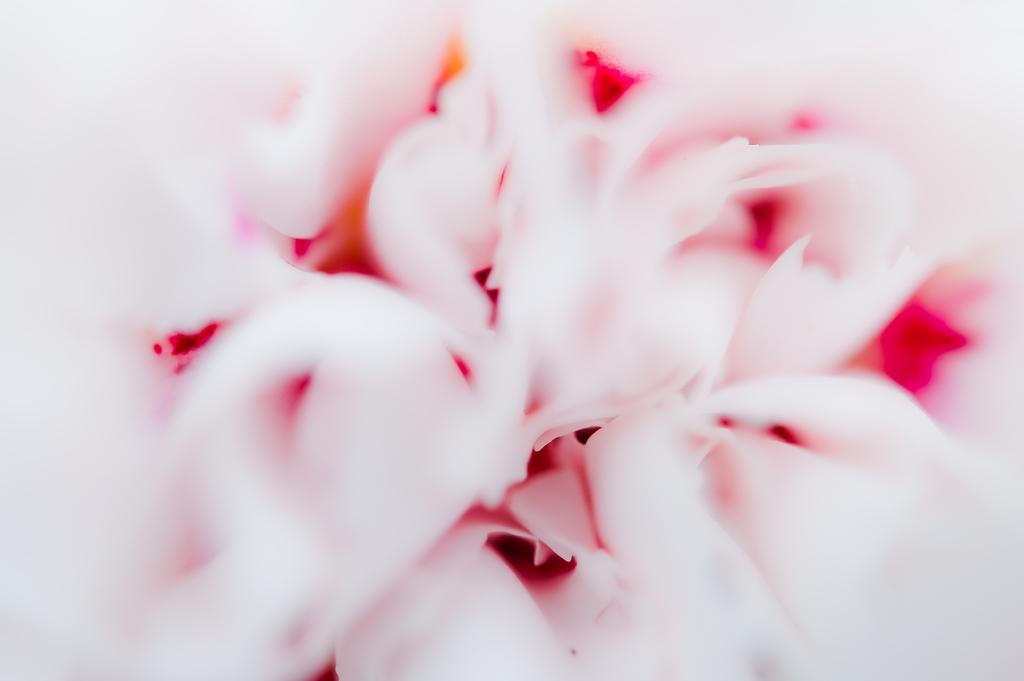Can you describe this image briefly? In this picture there is an object which is in light and dark pink color. 